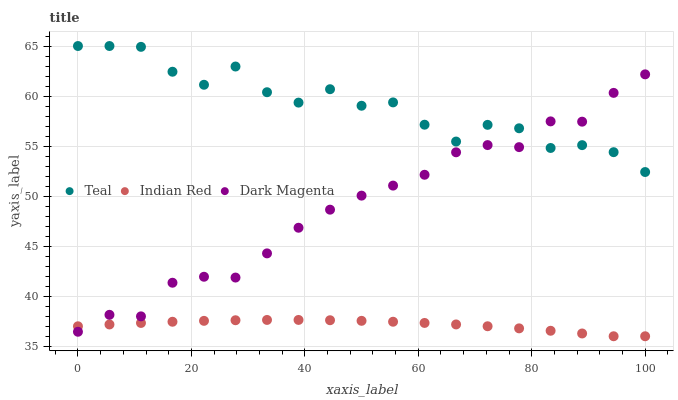Does Indian Red have the minimum area under the curve?
Answer yes or no. Yes. Does Teal have the maximum area under the curve?
Answer yes or no. Yes. Does Dark Magenta have the minimum area under the curve?
Answer yes or no. No. Does Dark Magenta have the maximum area under the curve?
Answer yes or no. No. Is Indian Red the smoothest?
Answer yes or no. Yes. Is Teal the roughest?
Answer yes or no. Yes. Is Dark Magenta the smoothest?
Answer yes or no. No. Is Dark Magenta the roughest?
Answer yes or no. No. Does Indian Red have the lowest value?
Answer yes or no. Yes. Does Dark Magenta have the lowest value?
Answer yes or no. No. Does Teal have the highest value?
Answer yes or no. Yes. Does Dark Magenta have the highest value?
Answer yes or no. No. Is Indian Red less than Teal?
Answer yes or no. Yes. Is Teal greater than Indian Red?
Answer yes or no. Yes. Does Dark Magenta intersect Teal?
Answer yes or no. Yes. Is Dark Magenta less than Teal?
Answer yes or no. No. Is Dark Magenta greater than Teal?
Answer yes or no. No. Does Indian Red intersect Teal?
Answer yes or no. No. 